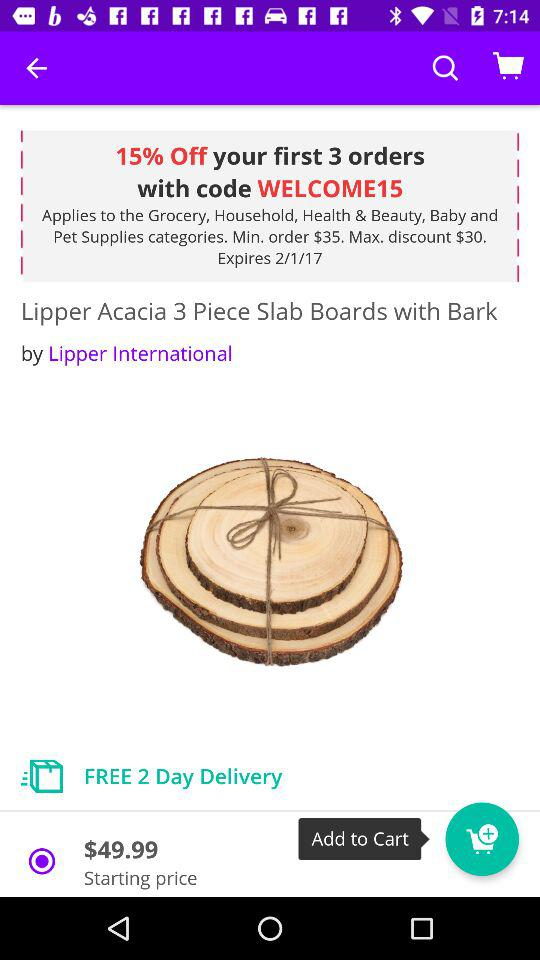How much is the discount off the product?
Answer the question using a single word or phrase. 15% 